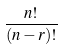<formula> <loc_0><loc_0><loc_500><loc_500>\frac { n ! } { ( n - r ) ! }</formula> 